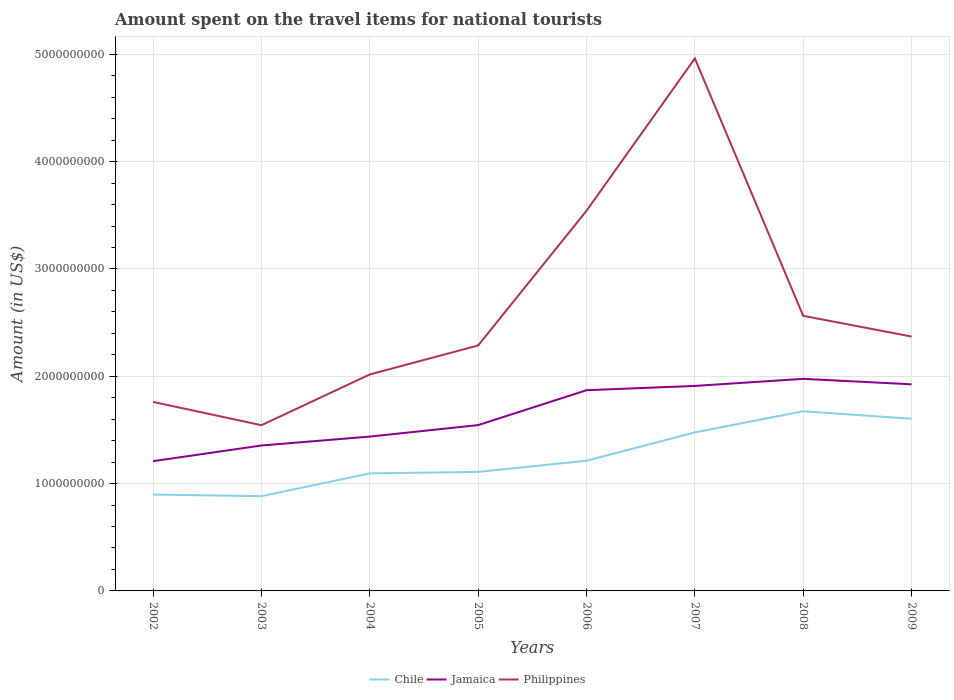How many different coloured lines are there?
Your response must be concise. 3. Across all years, what is the maximum amount spent on the travel items for national tourists in Philippines?
Your answer should be compact. 1.54e+09. In which year was the amount spent on the travel items for national tourists in Chile maximum?
Make the answer very short. 2003. What is the total amount spent on the travel items for national tourists in Jamaica in the graph?
Your response must be concise. -5.15e+08. What is the difference between the highest and the second highest amount spent on the travel items for national tourists in Jamaica?
Your answer should be very brief. 7.67e+08. What is the difference between the highest and the lowest amount spent on the travel items for national tourists in Jamaica?
Make the answer very short. 4. Is the amount spent on the travel items for national tourists in Chile strictly greater than the amount spent on the travel items for national tourists in Philippines over the years?
Provide a succinct answer. Yes. How many years are there in the graph?
Offer a very short reply. 8. Are the values on the major ticks of Y-axis written in scientific E-notation?
Offer a very short reply. No. Does the graph contain grids?
Your answer should be compact. Yes. How many legend labels are there?
Make the answer very short. 3. What is the title of the graph?
Give a very brief answer. Amount spent on the travel items for national tourists. What is the Amount (in US$) in Chile in 2002?
Provide a short and direct response. 8.98e+08. What is the Amount (in US$) in Jamaica in 2002?
Make the answer very short. 1.21e+09. What is the Amount (in US$) in Philippines in 2002?
Keep it short and to the point. 1.76e+09. What is the Amount (in US$) in Chile in 2003?
Provide a succinct answer. 8.83e+08. What is the Amount (in US$) of Jamaica in 2003?
Offer a terse response. 1.36e+09. What is the Amount (in US$) in Philippines in 2003?
Your response must be concise. 1.54e+09. What is the Amount (in US$) in Chile in 2004?
Offer a very short reply. 1.10e+09. What is the Amount (in US$) in Jamaica in 2004?
Your response must be concise. 1.44e+09. What is the Amount (in US$) in Philippines in 2004?
Your answer should be very brief. 2.02e+09. What is the Amount (in US$) in Chile in 2005?
Provide a succinct answer. 1.11e+09. What is the Amount (in US$) in Jamaica in 2005?
Offer a terse response. 1.54e+09. What is the Amount (in US$) in Philippines in 2005?
Offer a very short reply. 2.29e+09. What is the Amount (in US$) in Chile in 2006?
Offer a terse response. 1.21e+09. What is the Amount (in US$) in Jamaica in 2006?
Your response must be concise. 1.87e+09. What is the Amount (in US$) in Philippines in 2006?
Ensure brevity in your answer.  3.54e+09. What is the Amount (in US$) in Chile in 2007?
Your answer should be compact. 1.48e+09. What is the Amount (in US$) in Jamaica in 2007?
Give a very brief answer. 1.91e+09. What is the Amount (in US$) in Philippines in 2007?
Give a very brief answer. 4.96e+09. What is the Amount (in US$) in Chile in 2008?
Provide a short and direct response. 1.67e+09. What is the Amount (in US$) in Jamaica in 2008?
Make the answer very short. 1.98e+09. What is the Amount (in US$) in Philippines in 2008?
Make the answer very short. 2.56e+09. What is the Amount (in US$) in Chile in 2009?
Keep it short and to the point. 1.60e+09. What is the Amount (in US$) of Jamaica in 2009?
Your answer should be compact. 1.92e+09. What is the Amount (in US$) of Philippines in 2009?
Give a very brief answer. 2.37e+09. Across all years, what is the maximum Amount (in US$) of Chile?
Ensure brevity in your answer.  1.67e+09. Across all years, what is the maximum Amount (in US$) of Jamaica?
Your answer should be very brief. 1.98e+09. Across all years, what is the maximum Amount (in US$) of Philippines?
Provide a short and direct response. 4.96e+09. Across all years, what is the minimum Amount (in US$) of Chile?
Your answer should be compact. 8.83e+08. Across all years, what is the minimum Amount (in US$) of Jamaica?
Your response must be concise. 1.21e+09. Across all years, what is the minimum Amount (in US$) in Philippines?
Provide a succinct answer. 1.54e+09. What is the total Amount (in US$) of Chile in the graph?
Provide a succinct answer. 9.95e+09. What is the total Amount (in US$) in Jamaica in the graph?
Ensure brevity in your answer.  1.32e+1. What is the total Amount (in US$) in Philippines in the graph?
Offer a terse response. 2.10e+1. What is the difference between the Amount (in US$) in Chile in 2002 and that in 2003?
Make the answer very short. 1.50e+07. What is the difference between the Amount (in US$) of Jamaica in 2002 and that in 2003?
Your answer should be compact. -1.46e+08. What is the difference between the Amount (in US$) in Philippines in 2002 and that in 2003?
Your response must be concise. 2.17e+08. What is the difference between the Amount (in US$) of Chile in 2002 and that in 2004?
Make the answer very short. -1.97e+08. What is the difference between the Amount (in US$) of Jamaica in 2002 and that in 2004?
Make the answer very short. -2.29e+08. What is the difference between the Amount (in US$) in Philippines in 2002 and that in 2004?
Your answer should be very brief. -2.56e+08. What is the difference between the Amount (in US$) of Chile in 2002 and that in 2005?
Your answer should be very brief. -2.11e+08. What is the difference between the Amount (in US$) of Jamaica in 2002 and that in 2005?
Give a very brief answer. -3.36e+08. What is the difference between the Amount (in US$) of Philippines in 2002 and that in 2005?
Offer a very short reply. -5.26e+08. What is the difference between the Amount (in US$) of Chile in 2002 and that in 2006?
Your response must be concise. -3.15e+08. What is the difference between the Amount (in US$) in Jamaica in 2002 and that in 2006?
Provide a short and direct response. -6.61e+08. What is the difference between the Amount (in US$) of Philippines in 2002 and that in 2006?
Make the answer very short. -1.78e+09. What is the difference between the Amount (in US$) of Chile in 2002 and that in 2007?
Offer a terse response. -5.79e+08. What is the difference between the Amount (in US$) in Jamaica in 2002 and that in 2007?
Make the answer very short. -7.01e+08. What is the difference between the Amount (in US$) of Philippines in 2002 and that in 2007?
Offer a terse response. -3.20e+09. What is the difference between the Amount (in US$) of Chile in 2002 and that in 2008?
Your answer should be very brief. -7.76e+08. What is the difference between the Amount (in US$) of Jamaica in 2002 and that in 2008?
Give a very brief answer. -7.67e+08. What is the difference between the Amount (in US$) in Philippines in 2002 and that in 2008?
Your answer should be very brief. -8.02e+08. What is the difference between the Amount (in US$) of Chile in 2002 and that in 2009?
Offer a terse response. -7.06e+08. What is the difference between the Amount (in US$) in Jamaica in 2002 and that in 2009?
Offer a terse response. -7.16e+08. What is the difference between the Amount (in US$) of Philippines in 2002 and that in 2009?
Give a very brief answer. -6.09e+08. What is the difference between the Amount (in US$) of Chile in 2003 and that in 2004?
Your answer should be compact. -2.12e+08. What is the difference between the Amount (in US$) of Jamaica in 2003 and that in 2004?
Keep it short and to the point. -8.30e+07. What is the difference between the Amount (in US$) in Philippines in 2003 and that in 2004?
Offer a very short reply. -4.73e+08. What is the difference between the Amount (in US$) of Chile in 2003 and that in 2005?
Ensure brevity in your answer.  -2.26e+08. What is the difference between the Amount (in US$) of Jamaica in 2003 and that in 2005?
Offer a very short reply. -1.90e+08. What is the difference between the Amount (in US$) in Philippines in 2003 and that in 2005?
Make the answer very short. -7.43e+08. What is the difference between the Amount (in US$) in Chile in 2003 and that in 2006?
Your response must be concise. -3.30e+08. What is the difference between the Amount (in US$) in Jamaica in 2003 and that in 2006?
Offer a terse response. -5.15e+08. What is the difference between the Amount (in US$) in Philippines in 2003 and that in 2006?
Ensure brevity in your answer.  -2.00e+09. What is the difference between the Amount (in US$) of Chile in 2003 and that in 2007?
Keep it short and to the point. -5.94e+08. What is the difference between the Amount (in US$) of Jamaica in 2003 and that in 2007?
Make the answer very short. -5.55e+08. What is the difference between the Amount (in US$) in Philippines in 2003 and that in 2007?
Offer a terse response. -3.42e+09. What is the difference between the Amount (in US$) of Chile in 2003 and that in 2008?
Provide a succinct answer. -7.91e+08. What is the difference between the Amount (in US$) in Jamaica in 2003 and that in 2008?
Your answer should be compact. -6.21e+08. What is the difference between the Amount (in US$) in Philippines in 2003 and that in 2008?
Your response must be concise. -1.02e+09. What is the difference between the Amount (in US$) of Chile in 2003 and that in 2009?
Your answer should be very brief. -7.21e+08. What is the difference between the Amount (in US$) of Jamaica in 2003 and that in 2009?
Provide a succinct answer. -5.70e+08. What is the difference between the Amount (in US$) in Philippines in 2003 and that in 2009?
Your answer should be compact. -8.26e+08. What is the difference between the Amount (in US$) in Chile in 2004 and that in 2005?
Provide a short and direct response. -1.40e+07. What is the difference between the Amount (in US$) of Jamaica in 2004 and that in 2005?
Keep it short and to the point. -1.07e+08. What is the difference between the Amount (in US$) of Philippines in 2004 and that in 2005?
Give a very brief answer. -2.70e+08. What is the difference between the Amount (in US$) of Chile in 2004 and that in 2006?
Offer a terse response. -1.18e+08. What is the difference between the Amount (in US$) of Jamaica in 2004 and that in 2006?
Your response must be concise. -4.32e+08. What is the difference between the Amount (in US$) in Philippines in 2004 and that in 2006?
Provide a short and direct response. -1.52e+09. What is the difference between the Amount (in US$) in Chile in 2004 and that in 2007?
Your answer should be very brief. -3.82e+08. What is the difference between the Amount (in US$) of Jamaica in 2004 and that in 2007?
Provide a short and direct response. -4.72e+08. What is the difference between the Amount (in US$) in Philippines in 2004 and that in 2007?
Provide a short and direct response. -2.94e+09. What is the difference between the Amount (in US$) in Chile in 2004 and that in 2008?
Make the answer very short. -5.79e+08. What is the difference between the Amount (in US$) in Jamaica in 2004 and that in 2008?
Keep it short and to the point. -5.38e+08. What is the difference between the Amount (in US$) of Philippines in 2004 and that in 2008?
Your answer should be very brief. -5.46e+08. What is the difference between the Amount (in US$) of Chile in 2004 and that in 2009?
Give a very brief answer. -5.09e+08. What is the difference between the Amount (in US$) of Jamaica in 2004 and that in 2009?
Your answer should be very brief. -4.87e+08. What is the difference between the Amount (in US$) of Philippines in 2004 and that in 2009?
Keep it short and to the point. -3.53e+08. What is the difference between the Amount (in US$) of Chile in 2005 and that in 2006?
Your response must be concise. -1.04e+08. What is the difference between the Amount (in US$) of Jamaica in 2005 and that in 2006?
Offer a very short reply. -3.25e+08. What is the difference between the Amount (in US$) in Philippines in 2005 and that in 2006?
Your answer should be very brief. -1.26e+09. What is the difference between the Amount (in US$) of Chile in 2005 and that in 2007?
Make the answer very short. -3.68e+08. What is the difference between the Amount (in US$) in Jamaica in 2005 and that in 2007?
Provide a short and direct response. -3.65e+08. What is the difference between the Amount (in US$) of Philippines in 2005 and that in 2007?
Keep it short and to the point. -2.67e+09. What is the difference between the Amount (in US$) of Chile in 2005 and that in 2008?
Provide a short and direct response. -5.65e+08. What is the difference between the Amount (in US$) of Jamaica in 2005 and that in 2008?
Keep it short and to the point. -4.31e+08. What is the difference between the Amount (in US$) in Philippines in 2005 and that in 2008?
Offer a terse response. -2.76e+08. What is the difference between the Amount (in US$) of Chile in 2005 and that in 2009?
Offer a terse response. -4.95e+08. What is the difference between the Amount (in US$) of Jamaica in 2005 and that in 2009?
Make the answer very short. -3.80e+08. What is the difference between the Amount (in US$) in Philippines in 2005 and that in 2009?
Offer a terse response. -8.30e+07. What is the difference between the Amount (in US$) in Chile in 2006 and that in 2007?
Your answer should be very brief. -2.64e+08. What is the difference between the Amount (in US$) in Jamaica in 2006 and that in 2007?
Your response must be concise. -4.00e+07. What is the difference between the Amount (in US$) of Philippines in 2006 and that in 2007?
Make the answer very short. -1.42e+09. What is the difference between the Amount (in US$) in Chile in 2006 and that in 2008?
Offer a very short reply. -4.61e+08. What is the difference between the Amount (in US$) in Jamaica in 2006 and that in 2008?
Keep it short and to the point. -1.06e+08. What is the difference between the Amount (in US$) of Philippines in 2006 and that in 2008?
Your answer should be compact. 9.79e+08. What is the difference between the Amount (in US$) of Chile in 2006 and that in 2009?
Make the answer very short. -3.91e+08. What is the difference between the Amount (in US$) of Jamaica in 2006 and that in 2009?
Give a very brief answer. -5.50e+07. What is the difference between the Amount (in US$) of Philippines in 2006 and that in 2009?
Ensure brevity in your answer.  1.17e+09. What is the difference between the Amount (in US$) of Chile in 2007 and that in 2008?
Offer a terse response. -1.97e+08. What is the difference between the Amount (in US$) in Jamaica in 2007 and that in 2008?
Provide a short and direct response. -6.60e+07. What is the difference between the Amount (in US$) of Philippines in 2007 and that in 2008?
Your answer should be compact. 2.40e+09. What is the difference between the Amount (in US$) in Chile in 2007 and that in 2009?
Offer a terse response. -1.27e+08. What is the difference between the Amount (in US$) of Jamaica in 2007 and that in 2009?
Give a very brief answer. -1.50e+07. What is the difference between the Amount (in US$) of Philippines in 2007 and that in 2009?
Make the answer very short. 2.59e+09. What is the difference between the Amount (in US$) in Chile in 2008 and that in 2009?
Your answer should be compact. 7.00e+07. What is the difference between the Amount (in US$) in Jamaica in 2008 and that in 2009?
Make the answer very short. 5.10e+07. What is the difference between the Amount (in US$) of Philippines in 2008 and that in 2009?
Your answer should be compact. 1.93e+08. What is the difference between the Amount (in US$) in Chile in 2002 and the Amount (in US$) in Jamaica in 2003?
Keep it short and to the point. -4.57e+08. What is the difference between the Amount (in US$) of Chile in 2002 and the Amount (in US$) of Philippines in 2003?
Ensure brevity in your answer.  -6.46e+08. What is the difference between the Amount (in US$) in Jamaica in 2002 and the Amount (in US$) in Philippines in 2003?
Your response must be concise. -3.35e+08. What is the difference between the Amount (in US$) in Chile in 2002 and the Amount (in US$) in Jamaica in 2004?
Keep it short and to the point. -5.40e+08. What is the difference between the Amount (in US$) in Chile in 2002 and the Amount (in US$) in Philippines in 2004?
Ensure brevity in your answer.  -1.12e+09. What is the difference between the Amount (in US$) of Jamaica in 2002 and the Amount (in US$) of Philippines in 2004?
Your answer should be compact. -8.08e+08. What is the difference between the Amount (in US$) of Chile in 2002 and the Amount (in US$) of Jamaica in 2005?
Provide a short and direct response. -6.47e+08. What is the difference between the Amount (in US$) of Chile in 2002 and the Amount (in US$) of Philippines in 2005?
Provide a short and direct response. -1.39e+09. What is the difference between the Amount (in US$) of Jamaica in 2002 and the Amount (in US$) of Philippines in 2005?
Provide a short and direct response. -1.08e+09. What is the difference between the Amount (in US$) in Chile in 2002 and the Amount (in US$) in Jamaica in 2006?
Provide a succinct answer. -9.72e+08. What is the difference between the Amount (in US$) of Chile in 2002 and the Amount (in US$) of Philippines in 2006?
Make the answer very short. -2.64e+09. What is the difference between the Amount (in US$) in Jamaica in 2002 and the Amount (in US$) in Philippines in 2006?
Your response must be concise. -2.33e+09. What is the difference between the Amount (in US$) of Chile in 2002 and the Amount (in US$) of Jamaica in 2007?
Offer a very short reply. -1.01e+09. What is the difference between the Amount (in US$) of Chile in 2002 and the Amount (in US$) of Philippines in 2007?
Your answer should be very brief. -4.06e+09. What is the difference between the Amount (in US$) in Jamaica in 2002 and the Amount (in US$) in Philippines in 2007?
Give a very brief answer. -3.75e+09. What is the difference between the Amount (in US$) in Chile in 2002 and the Amount (in US$) in Jamaica in 2008?
Provide a short and direct response. -1.08e+09. What is the difference between the Amount (in US$) in Chile in 2002 and the Amount (in US$) in Philippines in 2008?
Your response must be concise. -1.66e+09. What is the difference between the Amount (in US$) of Jamaica in 2002 and the Amount (in US$) of Philippines in 2008?
Keep it short and to the point. -1.35e+09. What is the difference between the Amount (in US$) of Chile in 2002 and the Amount (in US$) of Jamaica in 2009?
Offer a very short reply. -1.03e+09. What is the difference between the Amount (in US$) of Chile in 2002 and the Amount (in US$) of Philippines in 2009?
Provide a short and direct response. -1.47e+09. What is the difference between the Amount (in US$) of Jamaica in 2002 and the Amount (in US$) of Philippines in 2009?
Make the answer very short. -1.16e+09. What is the difference between the Amount (in US$) in Chile in 2003 and the Amount (in US$) in Jamaica in 2004?
Offer a terse response. -5.55e+08. What is the difference between the Amount (in US$) of Chile in 2003 and the Amount (in US$) of Philippines in 2004?
Provide a succinct answer. -1.13e+09. What is the difference between the Amount (in US$) of Jamaica in 2003 and the Amount (in US$) of Philippines in 2004?
Give a very brief answer. -6.62e+08. What is the difference between the Amount (in US$) of Chile in 2003 and the Amount (in US$) of Jamaica in 2005?
Your answer should be very brief. -6.62e+08. What is the difference between the Amount (in US$) of Chile in 2003 and the Amount (in US$) of Philippines in 2005?
Make the answer very short. -1.40e+09. What is the difference between the Amount (in US$) of Jamaica in 2003 and the Amount (in US$) of Philippines in 2005?
Offer a very short reply. -9.32e+08. What is the difference between the Amount (in US$) in Chile in 2003 and the Amount (in US$) in Jamaica in 2006?
Give a very brief answer. -9.87e+08. What is the difference between the Amount (in US$) in Chile in 2003 and the Amount (in US$) in Philippines in 2006?
Your response must be concise. -2.66e+09. What is the difference between the Amount (in US$) of Jamaica in 2003 and the Amount (in US$) of Philippines in 2006?
Give a very brief answer. -2.19e+09. What is the difference between the Amount (in US$) in Chile in 2003 and the Amount (in US$) in Jamaica in 2007?
Keep it short and to the point. -1.03e+09. What is the difference between the Amount (in US$) of Chile in 2003 and the Amount (in US$) of Philippines in 2007?
Offer a very short reply. -4.08e+09. What is the difference between the Amount (in US$) of Jamaica in 2003 and the Amount (in US$) of Philippines in 2007?
Offer a terse response. -3.61e+09. What is the difference between the Amount (in US$) of Chile in 2003 and the Amount (in US$) of Jamaica in 2008?
Provide a short and direct response. -1.09e+09. What is the difference between the Amount (in US$) in Chile in 2003 and the Amount (in US$) in Philippines in 2008?
Offer a terse response. -1.68e+09. What is the difference between the Amount (in US$) of Jamaica in 2003 and the Amount (in US$) of Philippines in 2008?
Offer a very short reply. -1.21e+09. What is the difference between the Amount (in US$) of Chile in 2003 and the Amount (in US$) of Jamaica in 2009?
Provide a succinct answer. -1.04e+09. What is the difference between the Amount (in US$) in Chile in 2003 and the Amount (in US$) in Philippines in 2009?
Provide a short and direct response. -1.49e+09. What is the difference between the Amount (in US$) in Jamaica in 2003 and the Amount (in US$) in Philippines in 2009?
Your answer should be compact. -1.02e+09. What is the difference between the Amount (in US$) in Chile in 2004 and the Amount (in US$) in Jamaica in 2005?
Your answer should be very brief. -4.50e+08. What is the difference between the Amount (in US$) of Chile in 2004 and the Amount (in US$) of Philippines in 2005?
Provide a short and direct response. -1.19e+09. What is the difference between the Amount (in US$) of Jamaica in 2004 and the Amount (in US$) of Philippines in 2005?
Ensure brevity in your answer.  -8.49e+08. What is the difference between the Amount (in US$) in Chile in 2004 and the Amount (in US$) in Jamaica in 2006?
Make the answer very short. -7.75e+08. What is the difference between the Amount (in US$) of Chile in 2004 and the Amount (in US$) of Philippines in 2006?
Provide a succinct answer. -2.45e+09. What is the difference between the Amount (in US$) in Jamaica in 2004 and the Amount (in US$) in Philippines in 2006?
Ensure brevity in your answer.  -2.10e+09. What is the difference between the Amount (in US$) of Chile in 2004 and the Amount (in US$) of Jamaica in 2007?
Make the answer very short. -8.15e+08. What is the difference between the Amount (in US$) in Chile in 2004 and the Amount (in US$) in Philippines in 2007?
Your response must be concise. -3.87e+09. What is the difference between the Amount (in US$) of Jamaica in 2004 and the Amount (in US$) of Philippines in 2007?
Your response must be concise. -3.52e+09. What is the difference between the Amount (in US$) of Chile in 2004 and the Amount (in US$) of Jamaica in 2008?
Give a very brief answer. -8.81e+08. What is the difference between the Amount (in US$) of Chile in 2004 and the Amount (in US$) of Philippines in 2008?
Provide a succinct answer. -1.47e+09. What is the difference between the Amount (in US$) in Jamaica in 2004 and the Amount (in US$) in Philippines in 2008?
Provide a short and direct response. -1.12e+09. What is the difference between the Amount (in US$) in Chile in 2004 and the Amount (in US$) in Jamaica in 2009?
Give a very brief answer. -8.30e+08. What is the difference between the Amount (in US$) of Chile in 2004 and the Amount (in US$) of Philippines in 2009?
Ensure brevity in your answer.  -1.28e+09. What is the difference between the Amount (in US$) of Jamaica in 2004 and the Amount (in US$) of Philippines in 2009?
Make the answer very short. -9.32e+08. What is the difference between the Amount (in US$) of Chile in 2005 and the Amount (in US$) of Jamaica in 2006?
Offer a very short reply. -7.61e+08. What is the difference between the Amount (in US$) of Chile in 2005 and the Amount (in US$) of Philippines in 2006?
Provide a succinct answer. -2.43e+09. What is the difference between the Amount (in US$) in Jamaica in 2005 and the Amount (in US$) in Philippines in 2006?
Ensure brevity in your answer.  -2.00e+09. What is the difference between the Amount (in US$) in Chile in 2005 and the Amount (in US$) in Jamaica in 2007?
Your answer should be compact. -8.01e+08. What is the difference between the Amount (in US$) in Chile in 2005 and the Amount (in US$) in Philippines in 2007?
Provide a succinct answer. -3.85e+09. What is the difference between the Amount (in US$) in Jamaica in 2005 and the Amount (in US$) in Philippines in 2007?
Your answer should be very brief. -3.42e+09. What is the difference between the Amount (in US$) in Chile in 2005 and the Amount (in US$) in Jamaica in 2008?
Provide a short and direct response. -8.67e+08. What is the difference between the Amount (in US$) of Chile in 2005 and the Amount (in US$) of Philippines in 2008?
Ensure brevity in your answer.  -1.45e+09. What is the difference between the Amount (in US$) in Jamaica in 2005 and the Amount (in US$) in Philippines in 2008?
Provide a short and direct response. -1.02e+09. What is the difference between the Amount (in US$) in Chile in 2005 and the Amount (in US$) in Jamaica in 2009?
Ensure brevity in your answer.  -8.16e+08. What is the difference between the Amount (in US$) in Chile in 2005 and the Amount (in US$) in Philippines in 2009?
Your answer should be very brief. -1.26e+09. What is the difference between the Amount (in US$) in Jamaica in 2005 and the Amount (in US$) in Philippines in 2009?
Provide a succinct answer. -8.25e+08. What is the difference between the Amount (in US$) of Chile in 2006 and the Amount (in US$) of Jamaica in 2007?
Offer a terse response. -6.97e+08. What is the difference between the Amount (in US$) of Chile in 2006 and the Amount (in US$) of Philippines in 2007?
Keep it short and to the point. -3.75e+09. What is the difference between the Amount (in US$) of Jamaica in 2006 and the Amount (in US$) of Philippines in 2007?
Make the answer very short. -3.09e+09. What is the difference between the Amount (in US$) of Chile in 2006 and the Amount (in US$) of Jamaica in 2008?
Offer a very short reply. -7.63e+08. What is the difference between the Amount (in US$) in Chile in 2006 and the Amount (in US$) in Philippines in 2008?
Make the answer very short. -1.35e+09. What is the difference between the Amount (in US$) of Jamaica in 2006 and the Amount (in US$) of Philippines in 2008?
Your response must be concise. -6.93e+08. What is the difference between the Amount (in US$) of Chile in 2006 and the Amount (in US$) of Jamaica in 2009?
Make the answer very short. -7.12e+08. What is the difference between the Amount (in US$) in Chile in 2006 and the Amount (in US$) in Philippines in 2009?
Ensure brevity in your answer.  -1.16e+09. What is the difference between the Amount (in US$) in Jamaica in 2006 and the Amount (in US$) in Philippines in 2009?
Offer a very short reply. -5.00e+08. What is the difference between the Amount (in US$) in Chile in 2007 and the Amount (in US$) in Jamaica in 2008?
Your response must be concise. -4.99e+08. What is the difference between the Amount (in US$) in Chile in 2007 and the Amount (in US$) in Philippines in 2008?
Your answer should be compact. -1.09e+09. What is the difference between the Amount (in US$) in Jamaica in 2007 and the Amount (in US$) in Philippines in 2008?
Your answer should be very brief. -6.53e+08. What is the difference between the Amount (in US$) of Chile in 2007 and the Amount (in US$) of Jamaica in 2009?
Provide a succinct answer. -4.48e+08. What is the difference between the Amount (in US$) in Chile in 2007 and the Amount (in US$) in Philippines in 2009?
Your answer should be compact. -8.93e+08. What is the difference between the Amount (in US$) of Jamaica in 2007 and the Amount (in US$) of Philippines in 2009?
Your answer should be very brief. -4.60e+08. What is the difference between the Amount (in US$) of Chile in 2008 and the Amount (in US$) of Jamaica in 2009?
Make the answer very short. -2.51e+08. What is the difference between the Amount (in US$) of Chile in 2008 and the Amount (in US$) of Philippines in 2009?
Your response must be concise. -6.96e+08. What is the difference between the Amount (in US$) in Jamaica in 2008 and the Amount (in US$) in Philippines in 2009?
Your response must be concise. -3.94e+08. What is the average Amount (in US$) of Chile per year?
Provide a short and direct response. 1.24e+09. What is the average Amount (in US$) in Jamaica per year?
Offer a terse response. 1.65e+09. What is the average Amount (in US$) of Philippines per year?
Keep it short and to the point. 2.63e+09. In the year 2002, what is the difference between the Amount (in US$) in Chile and Amount (in US$) in Jamaica?
Provide a short and direct response. -3.11e+08. In the year 2002, what is the difference between the Amount (in US$) of Chile and Amount (in US$) of Philippines?
Provide a succinct answer. -8.63e+08. In the year 2002, what is the difference between the Amount (in US$) of Jamaica and Amount (in US$) of Philippines?
Make the answer very short. -5.52e+08. In the year 2003, what is the difference between the Amount (in US$) of Chile and Amount (in US$) of Jamaica?
Your response must be concise. -4.72e+08. In the year 2003, what is the difference between the Amount (in US$) of Chile and Amount (in US$) of Philippines?
Provide a short and direct response. -6.61e+08. In the year 2003, what is the difference between the Amount (in US$) in Jamaica and Amount (in US$) in Philippines?
Ensure brevity in your answer.  -1.89e+08. In the year 2004, what is the difference between the Amount (in US$) of Chile and Amount (in US$) of Jamaica?
Provide a short and direct response. -3.43e+08. In the year 2004, what is the difference between the Amount (in US$) in Chile and Amount (in US$) in Philippines?
Give a very brief answer. -9.22e+08. In the year 2004, what is the difference between the Amount (in US$) of Jamaica and Amount (in US$) of Philippines?
Provide a short and direct response. -5.79e+08. In the year 2005, what is the difference between the Amount (in US$) in Chile and Amount (in US$) in Jamaica?
Your answer should be very brief. -4.36e+08. In the year 2005, what is the difference between the Amount (in US$) in Chile and Amount (in US$) in Philippines?
Make the answer very short. -1.18e+09. In the year 2005, what is the difference between the Amount (in US$) of Jamaica and Amount (in US$) of Philippines?
Provide a succinct answer. -7.42e+08. In the year 2006, what is the difference between the Amount (in US$) in Chile and Amount (in US$) in Jamaica?
Make the answer very short. -6.57e+08. In the year 2006, what is the difference between the Amount (in US$) of Chile and Amount (in US$) of Philippines?
Offer a very short reply. -2.33e+09. In the year 2006, what is the difference between the Amount (in US$) in Jamaica and Amount (in US$) in Philippines?
Give a very brief answer. -1.67e+09. In the year 2007, what is the difference between the Amount (in US$) in Chile and Amount (in US$) in Jamaica?
Ensure brevity in your answer.  -4.33e+08. In the year 2007, what is the difference between the Amount (in US$) in Chile and Amount (in US$) in Philippines?
Provide a succinct answer. -3.48e+09. In the year 2007, what is the difference between the Amount (in US$) in Jamaica and Amount (in US$) in Philippines?
Provide a succinct answer. -3.05e+09. In the year 2008, what is the difference between the Amount (in US$) in Chile and Amount (in US$) in Jamaica?
Give a very brief answer. -3.02e+08. In the year 2008, what is the difference between the Amount (in US$) in Chile and Amount (in US$) in Philippines?
Ensure brevity in your answer.  -8.89e+08. In the year 2008, what is the difference between the Amount (in US$) of Jamaica and Amount (in US$) of Philippines?
Provide a short and direct response. -5.87e+08. In the year 2009, what is the difference between the Amount (in US$) in Chile and Amount (in US$) in Jamaica?
Provide a short and direct response. -3.21e+08. In the year 2009, what is the difference between the Amount (in US$) in Chile and Amount (in US$) in Philippines?
Your answer should be very brief. -7.66e+08. In the year 2009, what is the difference between the Amount (in US$) in Jamaica and Amount (in US$) in Philippines?
Your answer should be compact. -4.45e+08. What is the ratio of the Amount (in US$) of Chile in 2002 to that in 2003?
Your answer should be compact. 1.02. What is the ratio of the Amount (in US$) in Jamaica in 2002 to that in 2003?
Offer a terse response. 0.89. What is the ratio of the Amount (in US$) of Philippines in 2002 to that in 2003?
Your answer should be very brief. 1.14. What is the ratio of the Amount (in US$) in Chile in 2002 to that in 2004?
Offer a terse response. 0.82. What is the ratio of the Amount (in US$) of Jamaica in 2002 to that in 2004?
Keep it short and to the point. 0.84. What is the ratio of the Amount (in US$) in Philippines in 2002 to that in 2004?
Offer a terse response. 0.87. What is the ratio of the Amount (in US$) of Chile in 2002 to that in 2005?
Offer a very short reply. 0.81. What is the ratio of the Amount (in US$) in Jamaica in 2002 to that in 2005?
Provide a succinct answer. 0.78. What is the ratio of the Amount (in US$) in Philippines in 2002 to that in 2005?
Your response must be concise. 0.77. What is the ratio of the Amount (in US$) of Chile in 2002 to that in 2006?
Provide a short and direct response. 0.74. What is the ratio of the Amount (in US$) in Jamaica in 2002 to that in 2006?
Provide a short and direct response. 0.65. What is the ratio of the Amount (in US$) in Philippines in 2002 to that in 2006?
Ensure brevity in your answer.  0.5. What is the ratio of the Amount (in US$) in Chile in 2002 to that in 2007?
Your answer should be compact. 0.61. What is the ratio of the Amount (in US$) in Jamaica in 2002 to that in 2007?
Ensure brevity in your answer.  0.63. What is the ratio of the Amount (in US$) in Philippines in 2002 to that in 2007?
Your answer should be compact. 0.35. What is the ratio of the Amount (in US$) of Chile in 2002 to that in 2008?
Your answer should be very brief. 0.54. What is the ratio of the Amount (in US$) of Jamaica in 2002 to that in 2008?
Your response must be concise. 0.61. What is the ratio of the Amount (in US$) in Philippines in 2002 to that in 2008?
Your answer should be very brief. 0.69. What is the ratio of the Amount (in US$) of Chile in 2002 to that in 2009?
Offer a very short reply. 0.56. What is the ratio of the Amount (in US$) of Jamaica in 2002 to that in 2009?
Provide a succinct answer. 0.63. What is the ratio of the Amount (in US$) in Philippines in 2002 to that in 2009?
Provide a short and direct response. 0.74. What is the ratio of the Amount (in US$) in Chile in 2003 to that in 2004?
Your answer should be compact. 0.81. What is the ratio of the Amount (in US$) of Jamaica in 2003 to that in 2004?
Ensure brevity in your answer.  0.94. What is the ratio of the Amount (in US$) in Philippines in 2003 to that in 2004?
Offer a terse response. 0.77. What is the ratio of the Amount (in US$) of Chile in 2003 to that in 2005?
Ensure brevity in your answer.  0.8. What is the ratio of the Amount (in US$) of Jamaica in 2003 to that in 2005?
Your response must be concise. 0.88. What is the ratio of the Amount (in US$) of Philippines in 2003 to that in 2005?
Your answer should be compact. 0.68. What is the ratio of the Amount (in US$) in Chile in 2003 to that in 2006?
Keep it short and to the point. 0.73. What is the ratio of the Amount (in US$) in Jamaica in 2003 to that in 2006?
Ensure brevity in your answer.  0.72. What is the ratio of the Amount (in US$) in Philippines in 2003 to that in 2006?
Make the answer very short. 0.44. What is the ratio of the Amount (in US$) of Chile in 2003 to that in 2007?
Keep it short and to the point. 0.6. What is the ratio of the Amount (in US$) of Jamaica in 2003 to that in 2007?
Offer a very short reply. 0.71. What is the ratio of the Amount (in US$) of Philippines in 2003 to that in 2007?
Your answer should be compact. 0.31. What is the ratio of the Amount (in US$) in Chile in 2003 to that in 2008?
Your response must be concise. 0.53. What is the ratio of the Amount (in US$) in Jamaica in 2003 to that in 2008?
Give a very brief answer. 0.69. What is the ratio of the Amount (in US$) of Philippines in 2003 to that in 2008?
Make the answer very short. 0.6. What is the ratio of the Amount (in US$) of Chile in 2003 to that in 2009?
Ensure brevity in your answer.  0.55. What is the ratio of the Amount (in US$) of Jamaica in 2003 to that in 2009?
Offer a very short reply. 0.7. What is the ratio of the Amount (in US$) in Philippines in 2003 to that in 2009?
Ensure brevity in your answer.  0.65. What is the ratio of the Amount (in US$) in Chile in 2004 to that in 2005?
Provide a succinct answer. 0.99. What is the ratio of the Amount (in US$) in Jamaica in 2004 to that in 2005?
Ensure brevity in your answer.  0.93. What is the ratio of the Amount (in US$) in Philippines in 2004 to that in 2005?
Make the answer very short. 0.88. What is the ratio of the Amount (in US$) in Chile in 2004 to that in 2006?
Make the answer very short. 0.9. What is the ratio of the Amount (in US$) in Jamaica in 2004 to that in 2006?
Provide a succinct answer. 0.77. What is the ratio of the Amount (in US$) of Philippines in 2004 to that in 2006?
Keep it short and to the point. 0.57. What is the ratio of the Amount (in US$) in Chile in 2004 to that in 2007?
Ensure brevity in your answer.  0.74. What is the ratio of the Amount (in US$) of Jamaica in 2004 to that in 2007?
Your answer should be very brief. 0.75. What is the ratio of the Amount (in US$) in Philippines in 2004 to that in 2007?
Keep it short and to the point. 0.41. What is the ratio of the Amount (in US$) in Chile in 2004 to that in 2008?
Your answer should be compact. 0.65. What is the ratio of the Amount (in US$) of Jamaica in 2004 to that in 2008?
Offer a very short reply. 0.73. What is the ratio of the Amount (in US$) of Philippines in 2004 to that in 2008?
Ensure brevity in your answer.  0.79. What is the ratio of the Amount (in US$) of Chile in 2004 to that in 2009?
Give a very brief answer. 0.68. What is the ratio of the Amount (in US$) of Jamaica in 2004 to that in 2009?
Give a very brief answer. 0.75. What is the ratio of the Amount (in US$) in Philippines in 2004 to that in 2009?
Provide a succinct answer. 0.85. What is the ratio of the Amount (in US$) of Chile in 2005 to that in 2006?
Ensure brevity in your answer.  0.91. What is the ratio of the Amount (in US$) in Jamaica in 2005 to that in 2006?
Ensure brevity in your answer.  0.83. What is the ratio of the Amount (in US$) of Philippines in 2005 to that in 2006?
Give a very brief answer. 0.65. What is the ratio of the Amount (in US$) in Chile in 2005 to that in 2007?
Your answer should be compact. 0.75. What is the ratio of the Amount (in US$) of Jamaica in 2005 to that in 2007?
Keep it short and to the point. 0.81. What is the ratio of the Amount (in US$) of Philippines in 2005 to that in 2007?
Give a very brief answer. 0.46. What is the ratio of the Amount (in US$) of Chile in 2005 to that in 2008?
Provide a short and direct response. 0.66. What is the ratio of the Amount (in US$) of Jamaica in 2005 to that in 2008?
Your response must be concise. 0.78. What is the ratio of the Amount (in US$) in Philippines in 2005 to that in 2008?
Offer a very short reply. 0.89. What is the ratio of the Amount (in US$) in Chile in 2005 to that in 2009?
Keep it short and to the point. 0.69. What is the ratio of the Amount (in US$) in Jamaica in 2005 to that in 2009?
Ensure brevity in your answer.  0.8. What is the ratio of the Amount (in US$) in Chile in 2006 to that in 2007?
Offer a very short reply. 0.82. What is the ratio of the Amount (in US$) in Jamaica in 2006 to that in 2007?
Offer a terse response. 0.98. What is the ratio of the Amount (in US$) of Philippines in 2006 to that in 2007?
Offer a very short reply. 0.71. What is the ratio of the Amount (in US$) in Chile in 2006 to that in 2008?
Your response must be concise. 0.72. What is the ratio of the Amount (in US$) of Jamaica in 2006 to that in 2008?
Your answer should be very brief. 0.95. What is the ratio of the Amount (in US$) of Philippines in 2006 to that in 2008?
Ensure brevity in your answer.  1.38. What is the ratio of the Amount (in US$) of Chile in 2006 to that in 2009?
Your answer should be very brief. 0.76. What is the ratio of the Amount (in US$) of Jamaica in 2006 to that in 2009?
Keep it short and to the point. 0.97. What is the ratio of the Amount (in US$) of Philippines in 2006 to that in 2009?
Ensure brevity in your answer.  1.49. What is the ratio of the Amount (in US$) in Chile in 2007 to that in 2008?
Your response must be concise. 0.88. What is the ratio of the Amount (in US$) of Jamaica in 2007 to that in 2008?
Provide a short and direct response. 0.97. What is the ratio of the Amount (in US$) of Philippines in 2007 to that in 2008?
Keep it short and to the point. 1.94. What is the ratio of the Amount (in US$) of Chile in 2007 to that in 2009?
Your answer should be compact. 0.92. What is the ratio of the Amount (in US$) of Jamaica in 2007 to that in 2009?
Your answer should be compact. 0.99. What is the ratio of the Amount (in US$) in Philippines in 2007 to that in 2009?
Your answer should be very brief. 2.09. What is the ratio of the Amount (in US$) of Chile in 2008 to that in 2009?
Provide a succinct answer. 1.04. What is the ratio of the Amount (in US$) in Jamaica in 2008 to that in 2009?
Offer a very short reply. 1.03. What is the ratio of the Amount (in US$) in Philippines in 2008 to that in 2009?
Your answer should be compact. 1.08. What is the difference between the highest and the second highest Amount (in US$) of Chile?
Your answer should be very brief. 7.00e+07. What is the difference between the highest and the second highest Amount (in US$) in Jamaica?
Offer a terse response. 5.10e+07. What is the difference between the highest and the second highest Amount (in US$) in Philippines?
Provide a succinct answer. 1.42e+09. What is the difference between the highest and the lowest Amount (in US$) in Chile?
Offer a very short reply. 7.91e+08. What is the difference between the highest and the lowest Amount (in US$) in Jamaica?
Provide a short and direct response. 7.67e+08. What is the difference between the highest and the lowest Amount (in US$) of Philippines?
Give a very brief answer. 3.42e+09. 